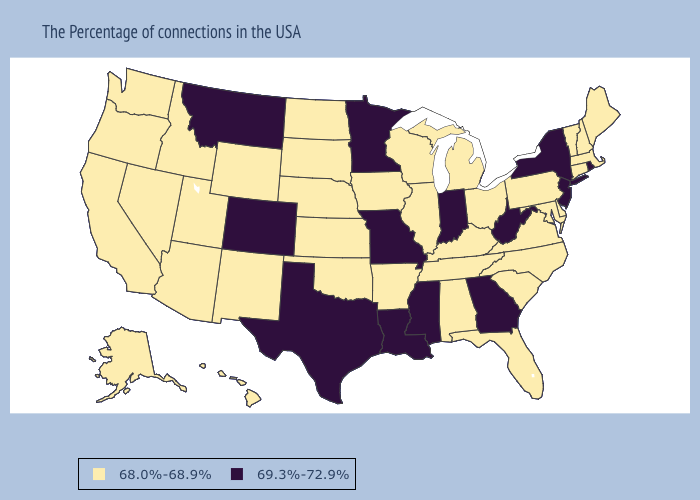What is the highest value in states that border Wisconsin?
Give a very brief answer. 69.3%-72.9%. Among the states that border New Mexico , does Colorado have the highest value?
Give a very brief answer. Yes. Does Missouri have the lowest value in the MidWest?
Write a very short answer. No. What is the highest value in states that border Florida?
Keep it brief. 69.3%-72.9%. What is the highest value in states that border Connecticut?
Answer briefly. 69.3%-72.9%. Name the states that have a value in the range 69.3%-72.9%?
Answer briefly. Rhode Island, New York, New Jersey, West Virginia, Georgia, Indiana, Mississippi, Louisiana, Missouri, Minnesota, Texas, Colorado, Montana. What is the value of South Carolina?
Short answer required. 68.0%-68.9%. What is the lowest value in the USA?
Answer briefly. 68.0%-68.9%. Does the first symbol in the legend represent the smallest category?
Keep it brief. Yes. Does New York have the lowest value in the USA?
Be succinct. No. Name the states that have a value in the range 69.3%-72.9%?
Be succinct. Rhode Island, New York, New Jersey, West Virginia, Georgia, Indiana, Mississippi, Louisiana, Missouri, Minnesota, Texas, Colorado, Montana. Name the states that have a value in the range 69.3%-72.9%?
Quick response, please. Rhode Island, New York, New Jersey, West Virginia, Georgia, Indiana, Mississippi, Louisiana, Missouri, Minnesota, Texas, Colorado, Montana. Does South Dakota have the lowest value in the MidWest?
Concise answer only. Yes. Is the legend a continuous bar?
Keep it brief. No. How many symbols are there in the legend?
Quick response, please. 2. 